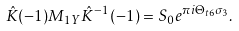Convert formula to latex. <formula><loc_0><loc_0><loc_500><loc_500>\hat { K } ( - 1 ) M _ { 1 Y } \hat { K } ^ { - 1 } ( - 1 ) = S _ { 0 } e ^ { \pi i \Theta _ { t 6 } \sigma _ { 3 } } .</formula> 